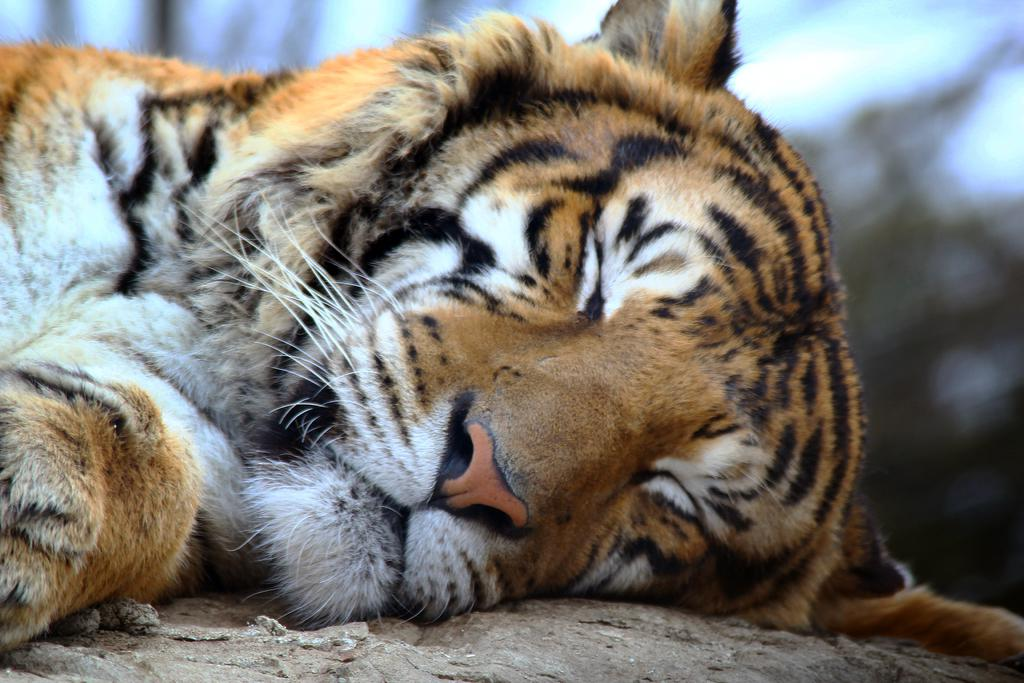What animal is the main subject of the image? There is a tiger in the image. What is the tiger's position in the image? The tiger is lying on a platform. Can you describe the background of the image? The background of the image is blurry. What type of linen is being used by the tiger's son in the image? There is no mention of a son or linen in the image, as it features a tiger lying on a platform with a blurry background. 